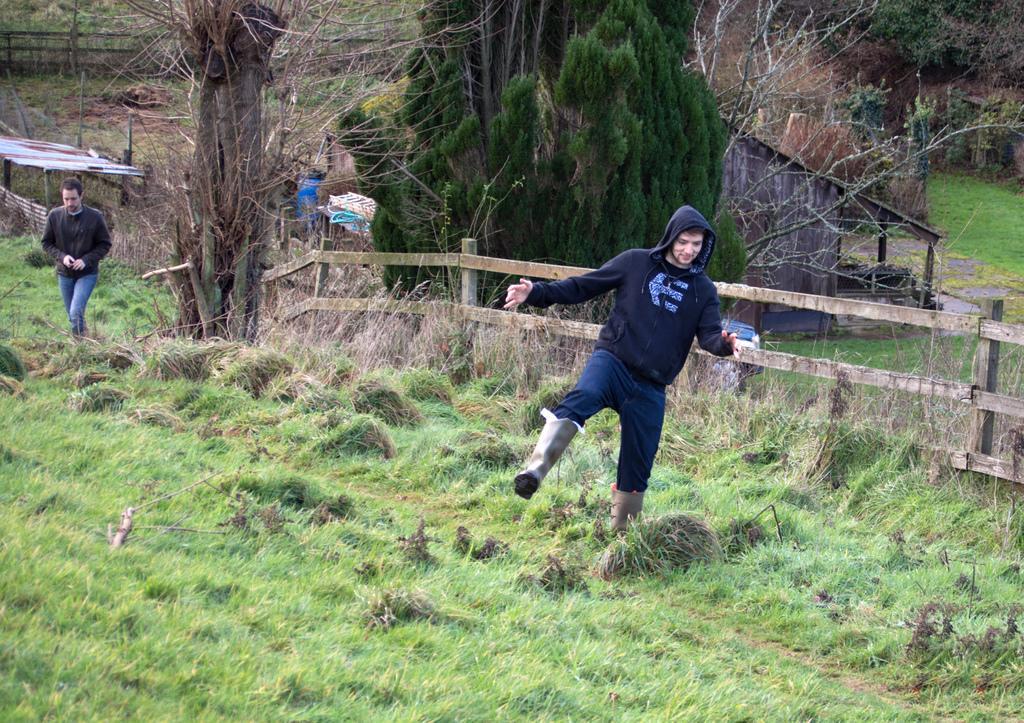How would you summarize this image in a sentence or two? In the picture there are two people walking on the grass and beside the grass there is a wooden fencing and behind the fencing there are few trees, a wooden house and also some dry plants. 